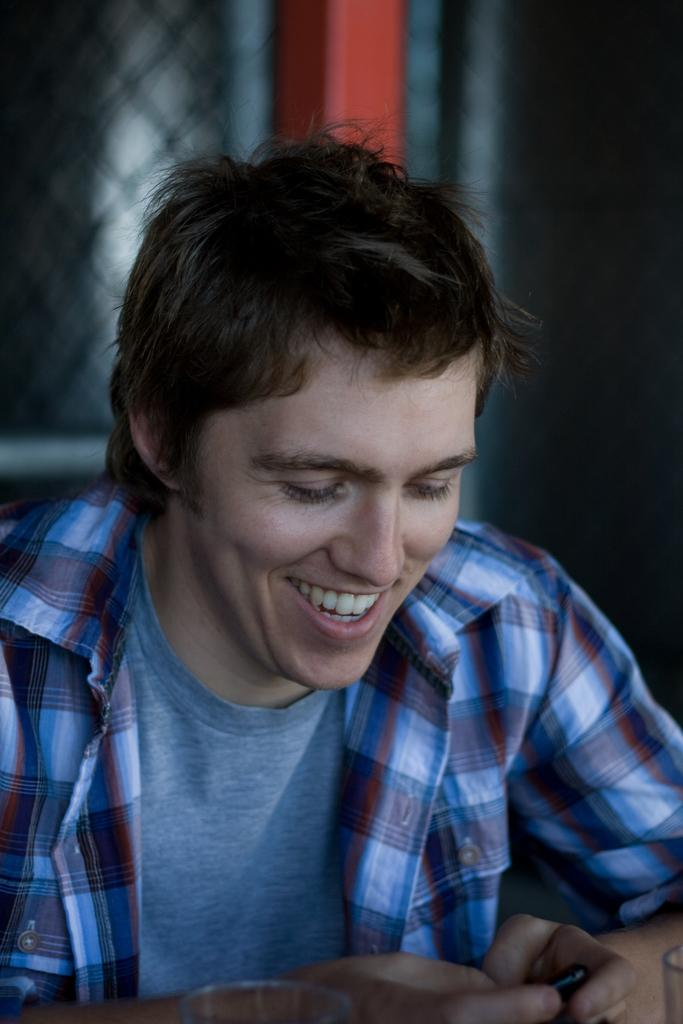Who is present in the image? There is a man in the image. What is the man doing in the image? The man is laughing in the image. Can you describe what the man is holding? The man appears to be holding an object in the image. What can be observed about the background of the image? The background of the man is blurred in the image. What type of shade is covering the man in the image? There is no shade covering the man in the image; the background is blurred, but no shade is present. 